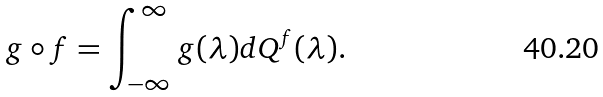Convert formula to latex. <formula><loc_0><loc_0><loc_500><loc_500>g \circ f = \int _ { - \infty } ^ { \infty } g ( \lambda ) d Q ^ { f } ( \lambda ) .</formula> 